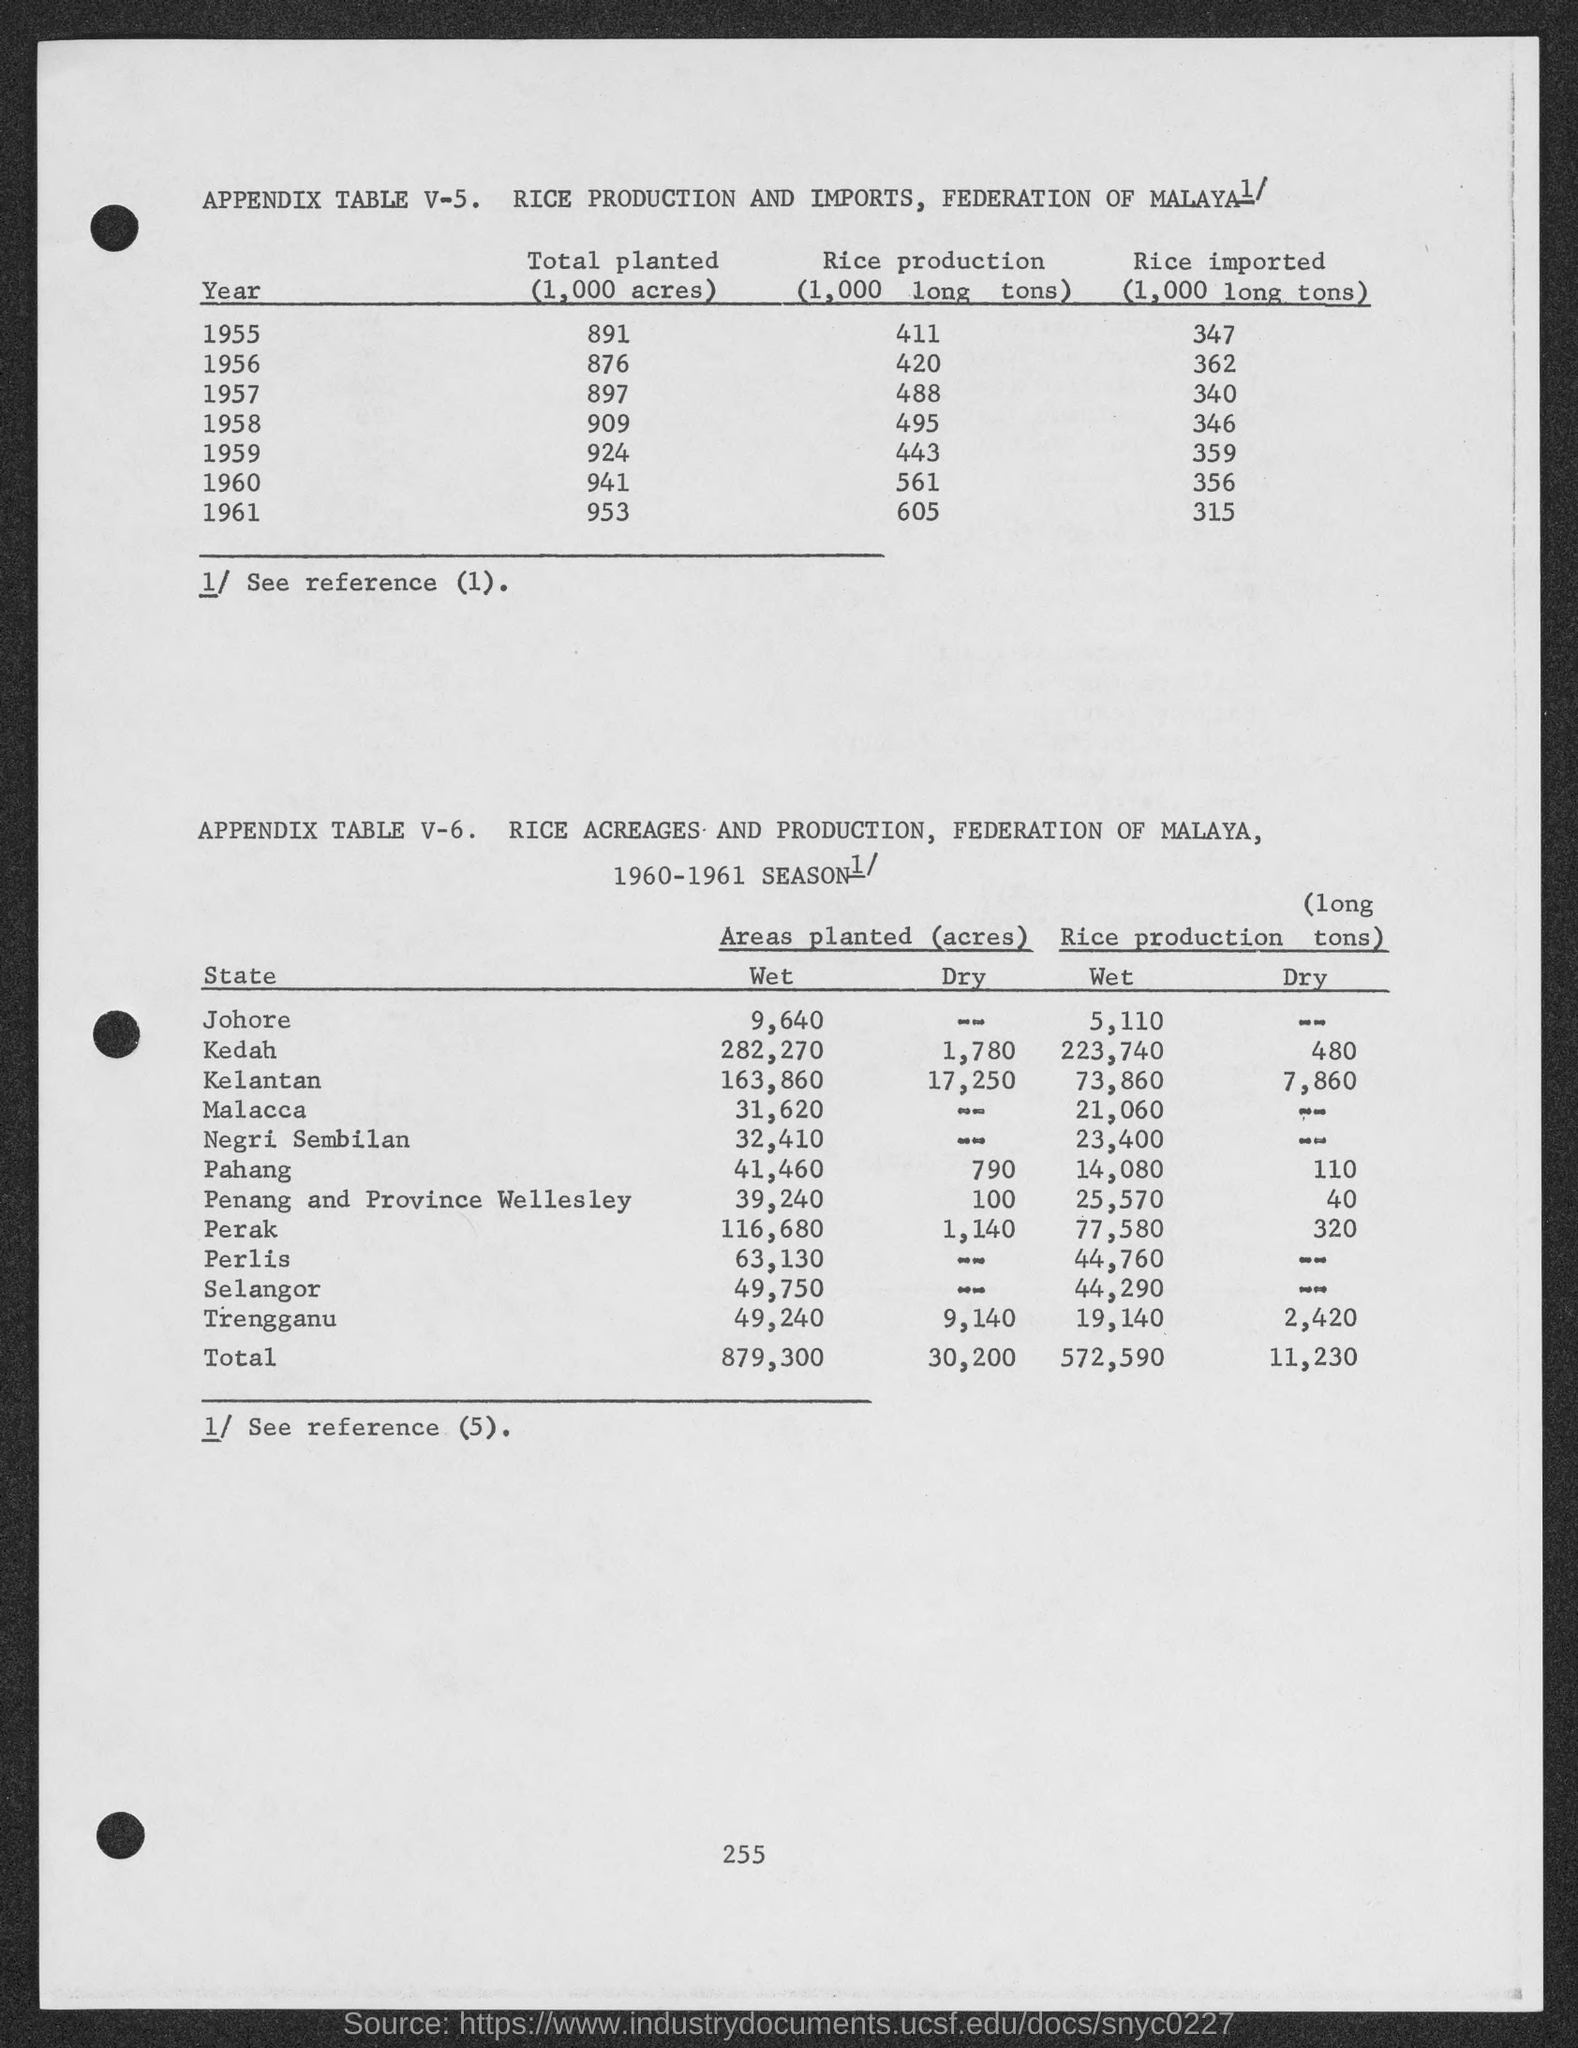Point out several critical features in this image. In the year 1959, the amount of rice imported was 359.. The total wet rice production mentioned in the given table is 572,590 metric tons. The total dry rice production mentioned in the given table is 11,230. The total amount of plants planted in the year 1955 was 891. The total amount of plants planted in the year 1956 is 876. 